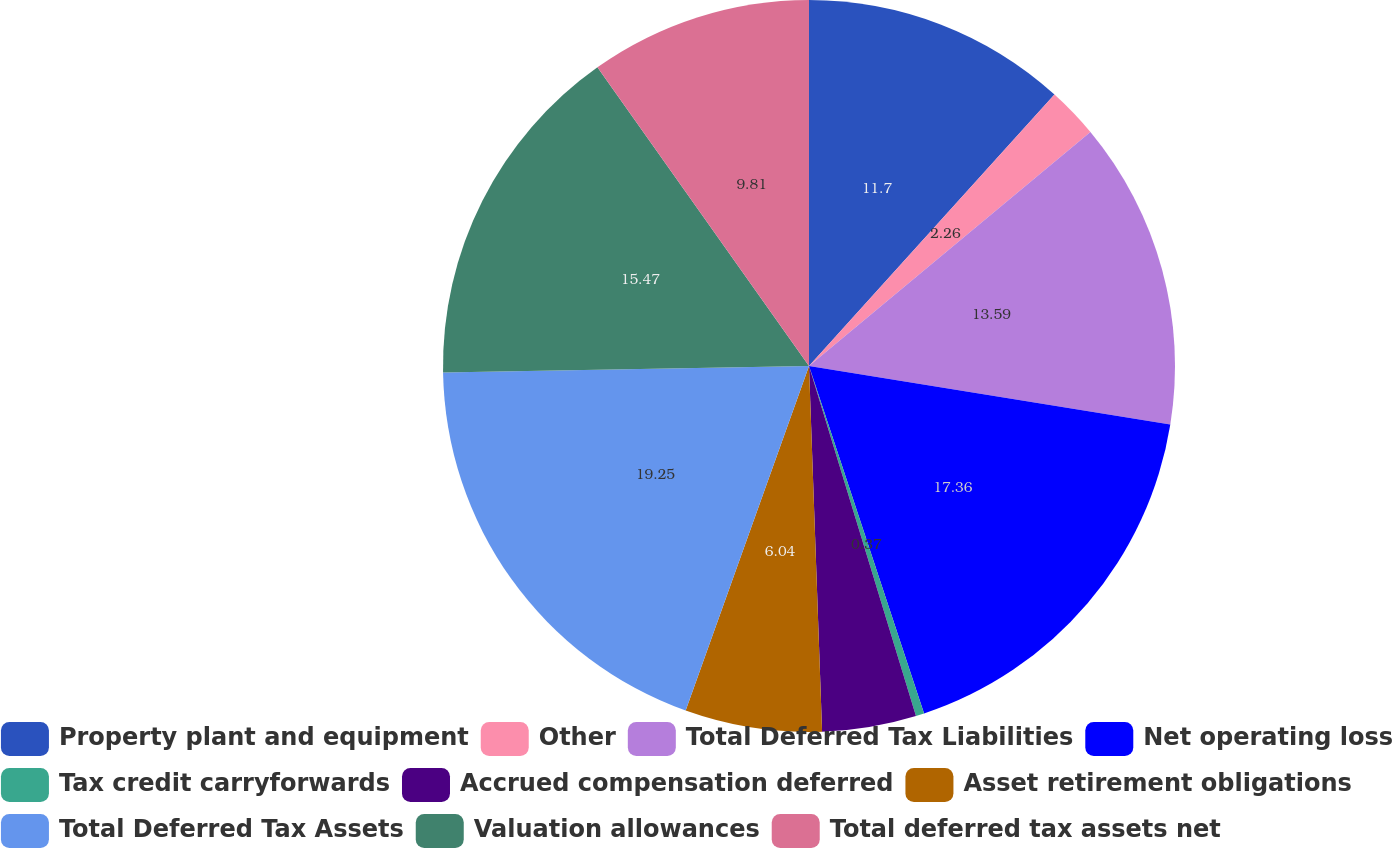<chart> <loc_0><loc_0><loc_500><loc_500><pie_chart><fcel>Property plant and equipment<fcel>Other<fcel>Total Deferred Tax Liabilities<fcel>Net operating loss<fcel>Tax credit carryforwards<fcel>Accrued compensation deferred<fcel>Asset retirement obligations<fcel>Total Deferred Tax Assets<fcel>Valuation allowances<fcel>Total deferred tax assets net<nl><fcel>11.7%<fcel>2.26%<fcel>13.59%<fcel>17.36%<fcel>0.37%<fcel>4.15%<fcel>6.04%<fcel>19.25%<fcel>15.47%<fcel>9.81%<nl></chart> 